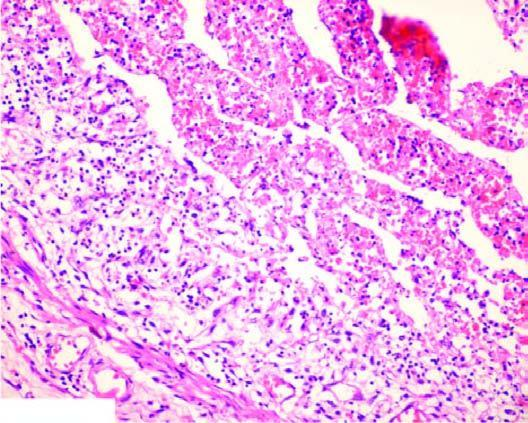s scanty cytoplasm and markedly hyperchromatic nuclei occluded by a thrombus containing microabscesses?
Answer the question using a single word or phrase. No 